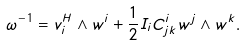Convert formula to latex. <formula><loc_0><loc_0><loc_500><loc_500>\omega ^ { - 1 } = v _ { i } ^ { H } \wedge w ^ { i } + \frac { 1 } { 2 } I _ { i } C ^ { i } _ { j k } w ^ { j } \wedge w ^ { k } .</formula> 